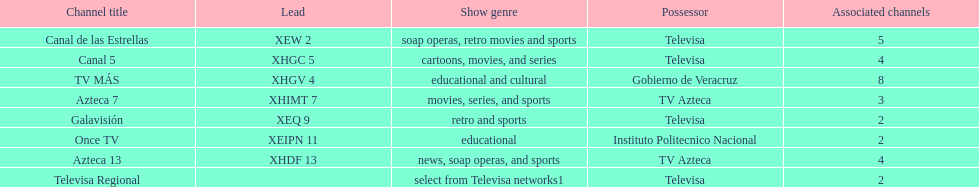How many networks have more affiliates than canal de las estrellas? 1. 